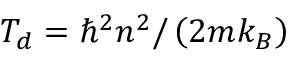Convert formula to latex. <formula><loc_0><loc_0><loc_500><loc_500>T _ { d } = \hbar { ^ } { 2 } n ^ { 2 } / \left ( 2 m k _ { B } \right )</formula> 